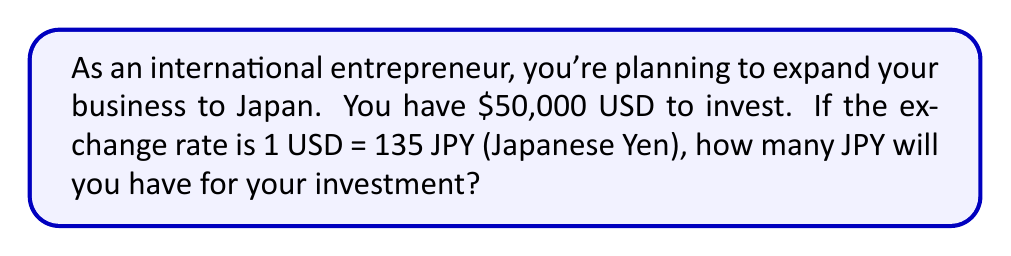Teach me how to tackle this problem. Let's approach this step-by-step:

1) We start with the given information:
   - Initial amount: $50,000 USD
   - Exchange rate: 1 USD = 135 JPY

2) To convert USD to JPY, we multiply the USD amount by the exchange rate:

   $$ \text{JPY} = \text{USD} \times \text{Exchange Rate} $$

3) Substituting our values:

   $$ \text{JPY} = 50,000 \times 135 $$

4) Perform the multiplication:

   $$ \text{JPY} = 6,750,000 $$

Therefore, $50,000 USD will convert to 6,750,000 JPY for your investment in Japan.
Answer: 6,750,000 JPY 